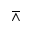<formula> <loc_0><loc_0><loc_500><loc_500>\bar { w } e d g e</formula> 